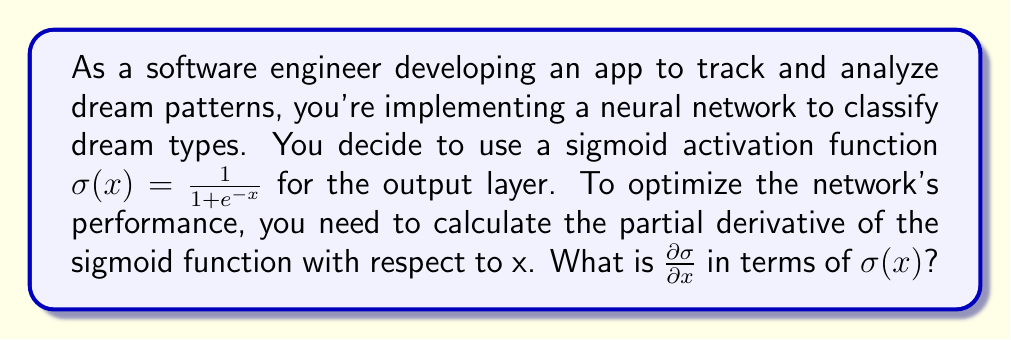Can you solve this math problem? To find the partial derivative of the sigmoid function, we'll use the chain rule:

1) Start with the sigmoid function: $\sigma(x) = \frac{1}{1 + e^{-x}}$

2) Let $u = 1 + e^{-x}$, so $\sigma(x) = \frac{1}{u}$

3) Apply the chain rule:
   $$\frac{\partial \sigma}{\partial x} = \frac{\partial \sigma}{\partial u} \cdot \frac{\partial u}{\partial x}$$

4) Calculate $\frac{\partial \sigma}{\partial u}$:
   $$\frac{\partial \sigma}{\partial u} = \frac{\partial}{\partial u}(u^{-1}) = -u^{-2} = -\frac{1}{(1 + e^{-x})^2}$$

5) Calculate $\frac{\partial u}{\partial x}$:
   $$\frac{\partial u}{\partial x} = \frac{\partial}{\partial x}(1 + e^{-x}) = -e^{-x}$$

6) Combine the results:
   $$\frac{\partial \sigma}{\partial x} = -\frac{1}{(1 + e^{-x})^2} \cdot (-e^{-x}) = \frac{e^{-x}}{(1 + e^{-x})^2}$$

7) Simplify using the definition of $\sigma(x)$:
   $$\frac{e^{-x}}{(1 + e^{-x})^2} = \frac{1}{1 + e^{-x}} \cdot \frac{e^{-x}}{1 + e^{-x}} = \sigma(x) \cdot (1 - \sigma(x))$$

Thus, we have derived that $\frac{\partial \sigma}{\partial x} = \sigma(x)(1 - \sigma(x))$.
Answer: $\frac{\partial \sigma}{\partial x} = \sigma(x)(1 - \sigma(x))$ 